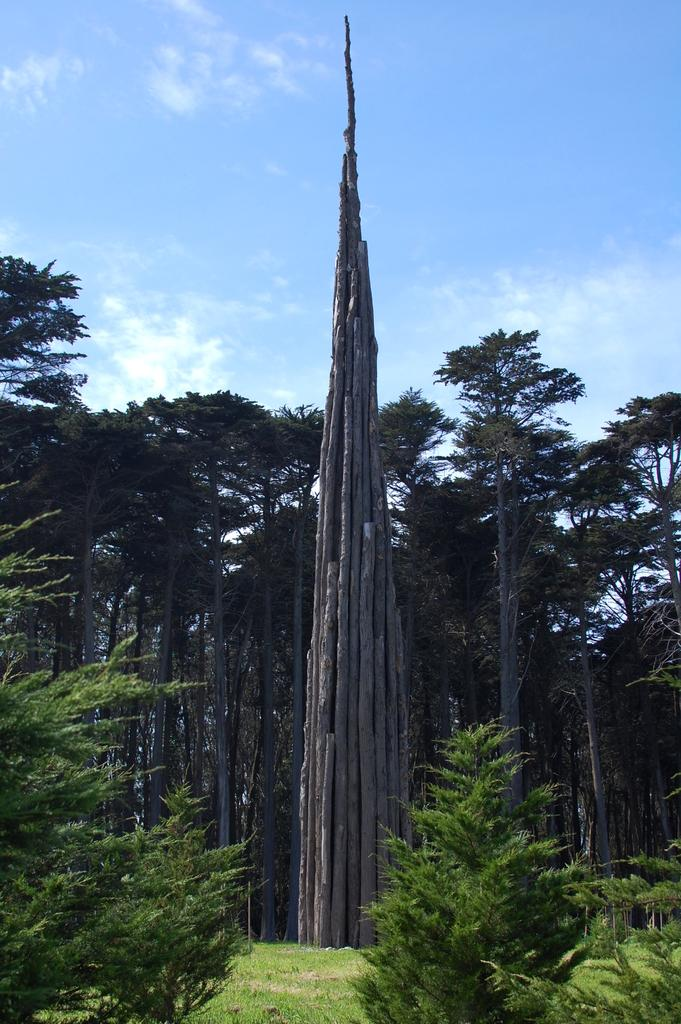What type of vegetation is present on the ground in the image? There is grass on the ground in the image. What color are the trees in the image? The trees in the image are green in color. What material are the logs made of in the image? The logs visible in the image are made of wood. How many trees can be seen in the image? There are more trees visible in the image. What can be seen in the background of the image? The sky is visible in the background of the image. Can you see a giraffe wearing a crown in the image? No, there is no giraffe or crown present in the image. What type of pickle is being used as a decoration in the image? There is no pickle present in the image. 